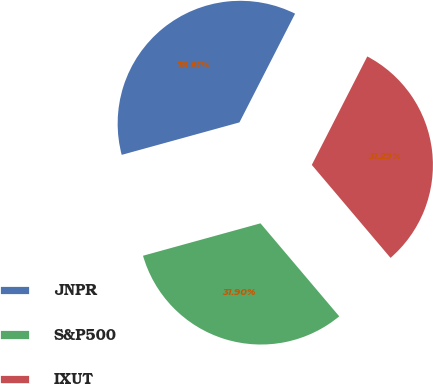Convert chart. <chart><loc_0><loc_0><loc_500><loc_500><pie_chart><fcel>JNPR<fcel>S&P500<fcel>IXUT<nl><fcel>36.81%<fcel>31.9%<fcel>31.29%<nl></chart> 